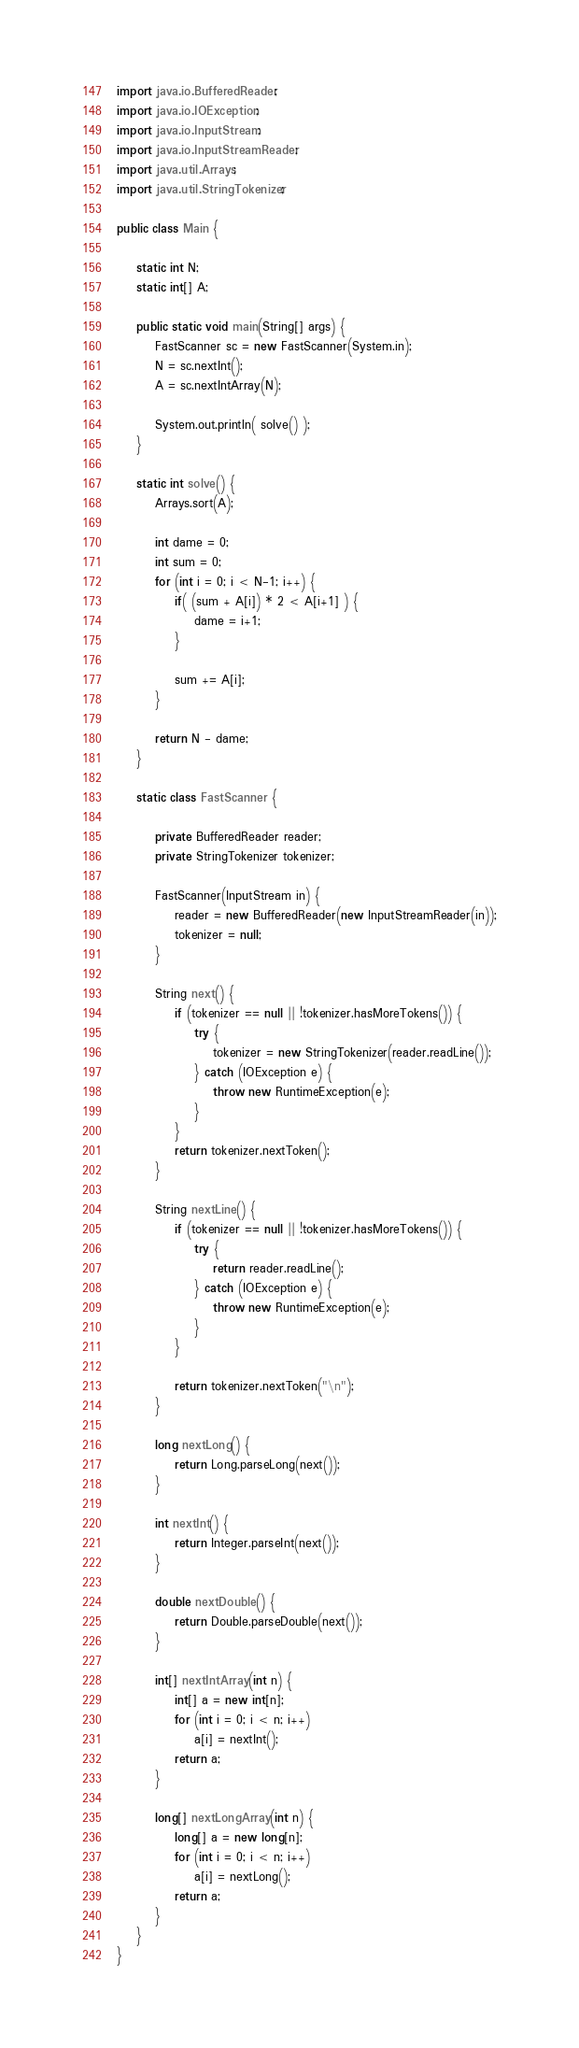Convert code to text. <code><loc_0><loc_0><loc_500><loc_500><_Java_>import java.io.BufferedReader;
import java.io.IOException;
import java.io.InputStream;
import java.io.InputStreamReader;
import java.util.Arrays;
import java.util.StringTokenizer;

public class Main {

    static int N;
    static int[] A;

    public static void main(String[] args) {
        FastScanner sc = new FastScanner(System.in);
        N = sc.nextInt();
        A = sc.nextIntArray(N);

        System.out.println( solve() );
    }

    static int solve() {
        Arrays.sort(A);

        int dame = 0;
        int sum = 0;
        for (int i = 0; i < N-1; i++) {
            if( (sum + A[i]) * 2 < A[i+1] ) {
                dame = i+1;
            }

            sum += A[i];
        }

        return N - dame;
    }

    static class FastScanner {

        private BufferedReader reader;
        private StringTokenizer tokenizer;

        FastScanner(InputStream in) {
            reader = new BufferedReader(new InputStreamReader(in));
            tokenizer = null;
        }

        String next() {
            if (tokenizer == null || !tokenizer.hasMoreTokens()) {
                try {
                    tokenizer = new StringTokenizer(reader.readLine());
                } catch (IOException e) {
                    throw new RuntimeException(e);
                }
            }
            return tokenizer.nextToken();
        }

        String nextLine() {
            if (tokenizer == null || !tokenizer.hasMoreTokens()) {
                try {
                    return reader.readLine();
                } catch (IOException e) {
                    throw new RuntimeException(e);
                }
            }

            return tokenizer.nextToken("\n");
        }

        long nextLong() {
            return Long.parseLong(next());
        }

        int nextInt() {
            return Integer.parseInt(next());
        }

        double nextDouble() {
            return Double.parseDouble(next());
        }

        int[] nextIntArray(int n) {
            int[] a = new int[n];
            for (int i = 0; i < n; i++)
                a[i] = nextInt();
            return a;
        }

        long[] nextLongArray(int n) {
            long[] a = new long[n];
            for (int i = 0; i < n; i++)
                a[i] = nextLong();
            return a;
        }
    }
}

</code> 